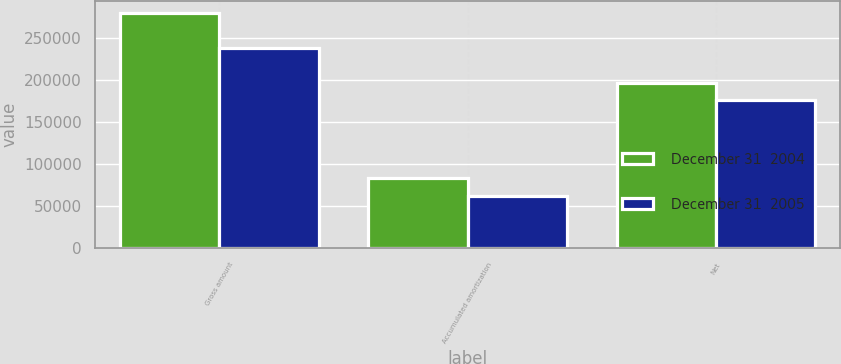Convert chart to OTSL. <chart><loc_0><loc_0><loc_500><loc_500><stacked_bar_chart><ecel><fcel>Gross amount<fcel>Accumulated amortization<fcel>Net<nl><fcel>December 31  2004<fcel>280561<fcel>83547<fcel>197014<nl><fcel>December 31  2005<fcel>238064<fcel>61942<fcel>176122<nl></chart> 